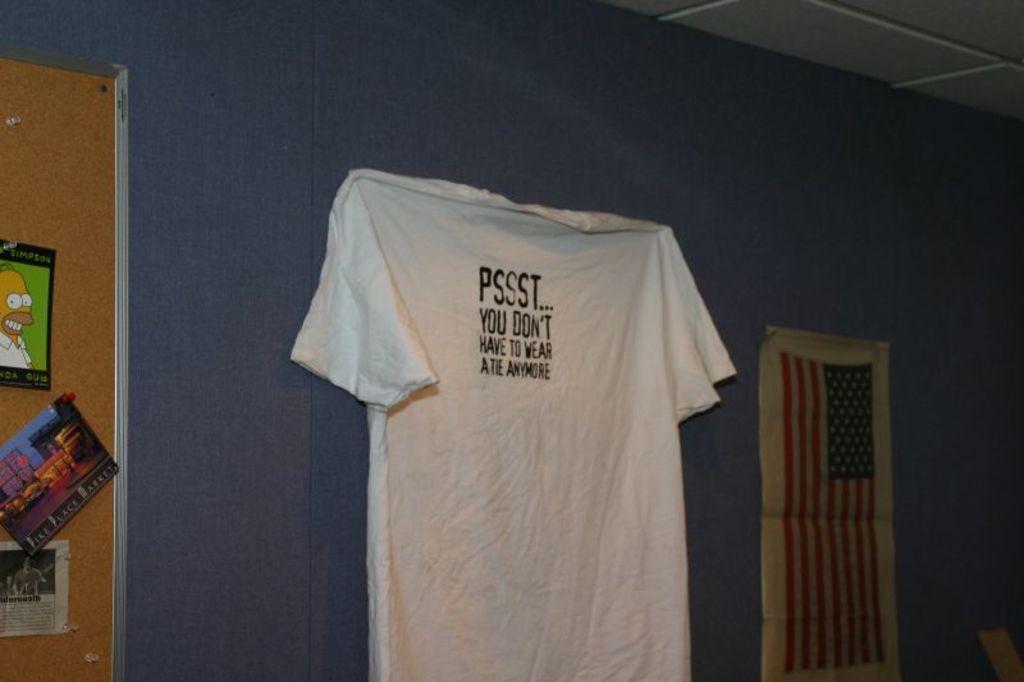What does the shirt say?
Offer a very short reply. Pssst... you don't have to wear a tie anymore. 